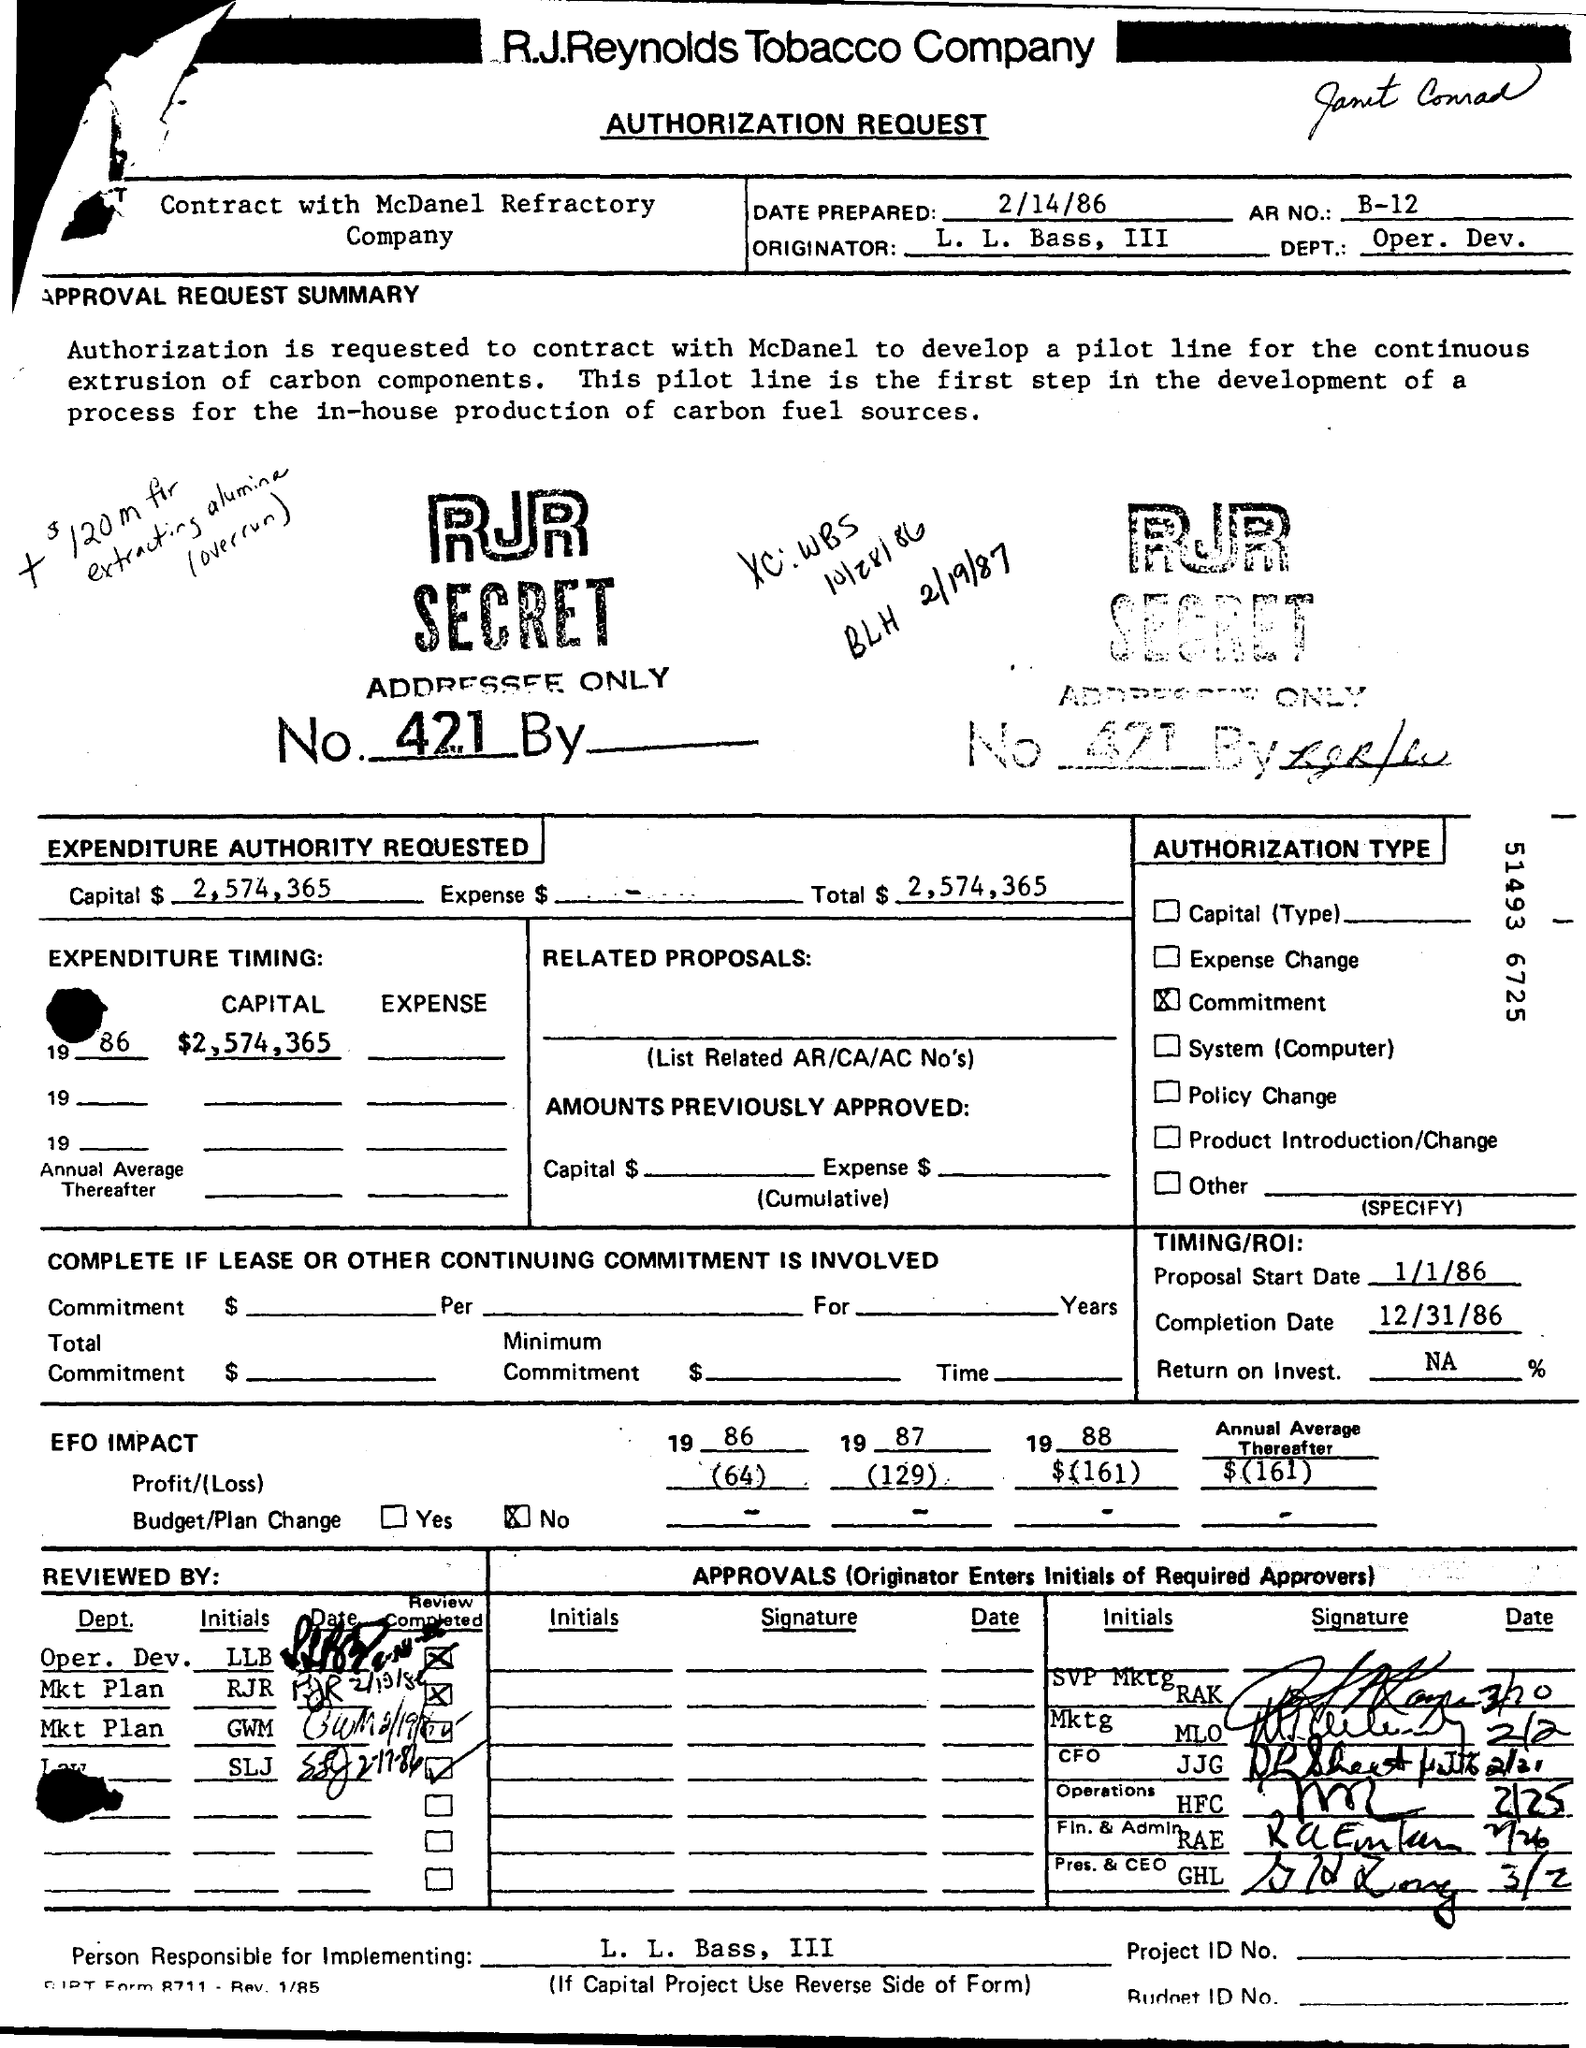Specify some key components in this picture. The AR number is B-12. The person responsible for implementing is L. L. Bass, III. The Department of Operations and Development is a department that focuses on the operations and development of the organization. The originator is L. L. Bass, III. The completion date is December 31, 1986. 